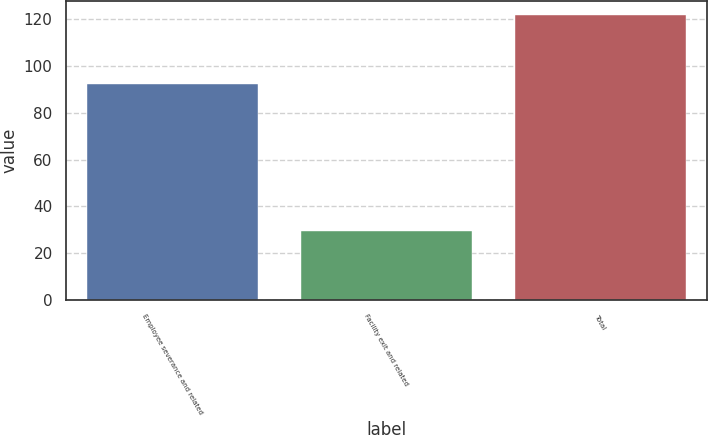Convert chart to OTSL. <chart><loc_0><loc_0><loc_500><loc_500><bar_chart><fcel>Employee severance and related<fcel>Facility exit and related<fcel>Total<nl><fcel>92.3<fcel>29.5<fcel>121.8<nl></chart> 